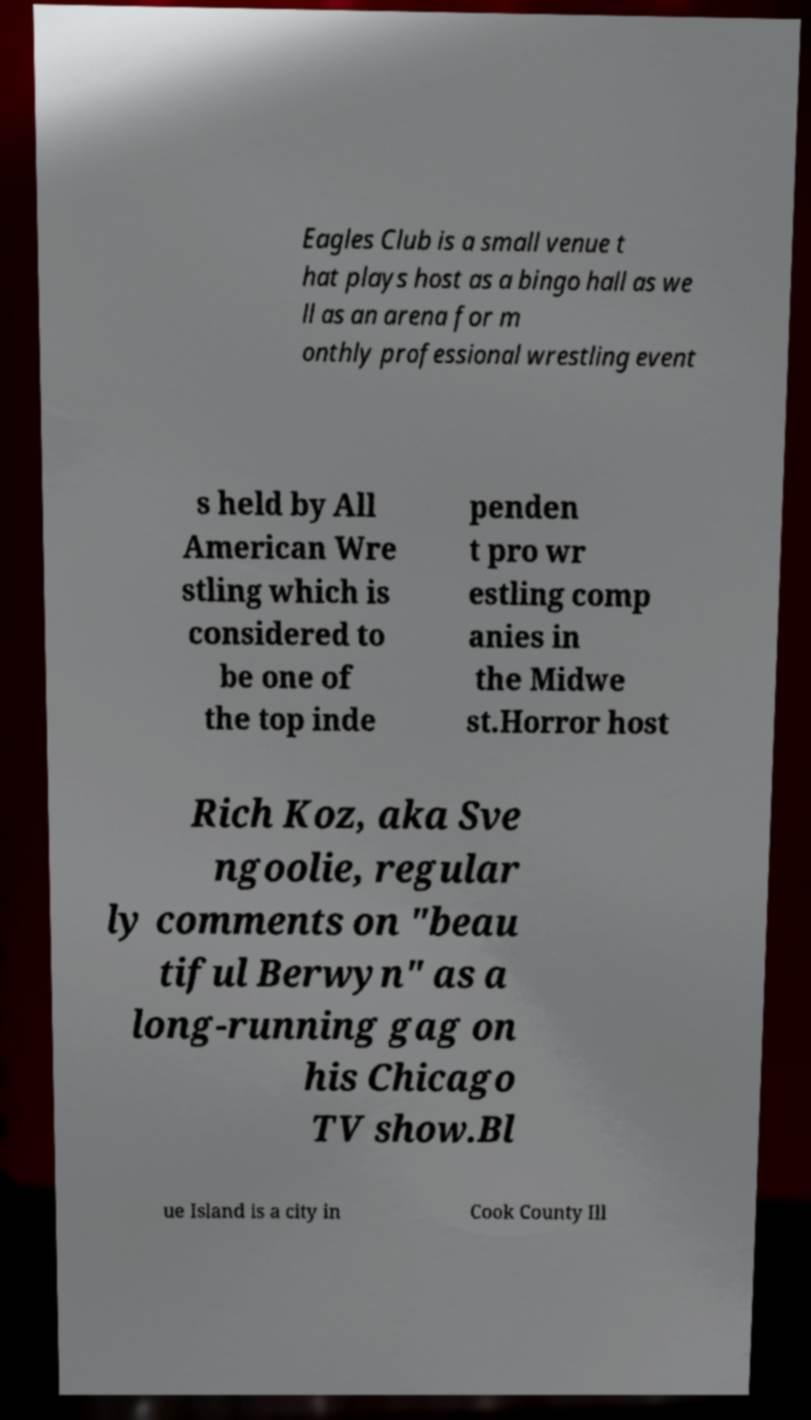Please read and relay the text visible in this image. What does it say? Eagles Club is a small venue t hat plays host as a bingo hall as we ll as an arena for m onthly professional wrestling event s held by All American Wre stling which is considered to be one of the top inde penden t pro wr estling comp anies in the Midwe st.Horror host Rich Koz, aka Sve ngoolie, regular ly comments on "beau tiful Berwyn" as a long-running gag on his Chicago TV show.Bl ue Island is a city in Cook County Ill 